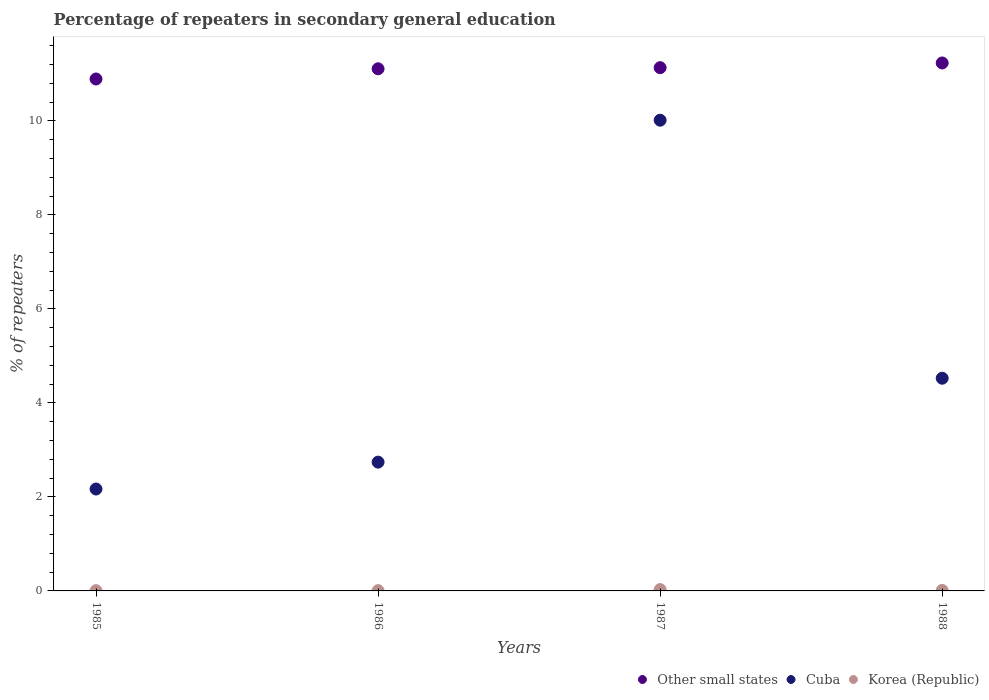How many different coloured dotlines are there?
Keep it short and to the point. 3. Is the number of dotlines equal to the number of legend labels?
Provide a short and direct response. Yes. What is the percentage of repeaters in secondary general education in Other small states in 1988?
Offer a very short reply. 11.23. Across all years, what is the maximum percentage of repeaters in secondary general education in Other small states?
Provide a succinct answer. 11.23. Across all years, what is the minimum percentage of repeaters in secondary general education in Cuba?
Offer a very short reply. 2.17. In which year was the percentage of repeaters in secondary general education in Korea (Republic) maximum?
Keep it short and to the point. 1987. What is the total percentage of repeaters in secondary general education in Korea (Republic) in the graph?
Keep it short and to the point. 0.05. What is the difference between the percentage of repeaters in secondary general education in Korea (Republic) in 1987 and that in 1988?
Give a very brief answer. 0.02. What is the difference between the percentage of repeaters in secondary general education in Korea (Republic) in 1985 and the percentage of repeaters in secondary general education in Other small states in 1987?
Keep it short and to the point. -11.13. What is the average percentage of repeaters in secondary general education in Other small states per year?
Offer a terse response. 11.09. In the year 1986, what is the difference between the percentage of repeaters in secondary general education in Other small states and percentage of repeaters in secondary general education in Korea (Republic)?
Provide a short and direct response. 11.1. In how many years, is the percentage of repeaters in secondary general education in Korea (Republic) greater than 6.8 %?
Offer a very short reply. 0. What is the ratio of the percentage of repeaters in secondary general education in Other small states in 1986 to that in 1988?
Offer a very short reply. 0.99. Is the percentage of repeaters in secondary general education in Cuba in 1986 less than that in 1988?
Ensure brevity in your answer.  Yes. Is the difference between the percentage of repeaters in secondary general education in Other small states in 1985 and 1988 greater than the difference between the percentage of repeaters in secondary general education in Korea (Republic) in 1985 and 1988?
Provide a short and direct response. No. What is the difference between the highest and the second highest percentage of repeaters in secondary general education in Other small states?
Offer a terse response. 0.1. What is the difference between the highest and the lowest percentage of repeaters in secondary general education in Korea (Republic)?
Offer a very short reply. 0.02. In how many years, is the percentage of repeaters in secondary general education in Cuba greater than the average percentage of repeaters in secondary general education in Cuba taken over all years?
Provide a succinct answer. 1. Is the sum of the percentage of repeaters in secondary general education in Korea (Republic) in 1985 and 1986 greater than the maximum percentage of repeaters in secondary general education in Cuba across all years?
Give a very brief answer. No. Is the percentage of repeaters in secondary general education in Other small states strictly less than the percentage of repeaters in secondary general education in Cuba over the years?
Your answer should be compact. No. How many dotlines are there?
Your answer should be compact. 3. Are the values on the major ticks of Y-axis written in scientific E-notation?
Keep it short and to the point. No. Where does the legend appear in the graph?
Provide a succinct answer. Bottom right. How many legend labels are there?
Ensure brevity in your answer.  3. What is the title of the graph?
Your response must be concise. Percentage of repeaters in secondary general education. Does "Peru" appear as one of the legend labels in the graph?
Your answer should be compact. No. What is the label or title of the Y-axis?
Give a very brief answer. % of repeaters. What is the % of repeaters in Other small states in 1985?
Provide a succinct answer. 10.89. What is the % of repeaters of Cuba in 1985?
Offer a terse response. 2.17. What is the % of repeaters of Korea (Republic) in 1985?
Make the answer very short. 0.01. What is the % of repeaters of Other small states in 1986?
Give a very brief answer. 11.11. What is the % of repeaters of Cuba in 1986?
Give a very brief answer. 2.74. What is the % of repeaters of Korea (Republic) in 1986?
Make the answer very short. 0.01. What is the % of repeaters of Other small states in 1987?
Give a very brief answer. 11.13. What is the % of repeaters in Cuba in 1987?
Offer a terse response. 10.01. What is the % of repeaters in Korea (Republic) in 1987?
Provide a succinct answer. 0.03. What is the % of repeaters of Other small states in 1988?
Make the answer very short. 11.23. What is the % of repeaters of Cuba in 1988?
Offer a very short reply. 4.52. What is the % of repeaters in Korea (Republic) in 1988?
Provide a succinct answer. 0.01. Across all years, what is the maximum % of repeaters of Other small states?
Your response must be concise. 11.23. Across all years, what is the maximum % of repeaters of Cuba?
Your answer should be very brief. 10.01. Across all years, what is the maximum % of repeaters of Korea (Republic)?
Offer a terse response. 0.03. Across all years, what is the minimum % of repeaters in Other small states?
Keep it short and to the point. 10.89. Across all years, what is the minimum % of repeaters in Cuba?
Make the answer very short. 2.17. Across all years, what is the minimum % of repeaters of Korea (Republic)?
Offer a very short reply. 0.01. What is the total % of repeaters of Other small states in the graph?
Offer a terse response. 44.36. What is the total % of repeaters in Cuba in the graph?
Offer a very short reply. 19.44. What is the total % of repeaters in Korea (Republic) in the graph?
Provide a succinct answer. 0.05. What is the difference between the % of repeaters of Other small states in 1985 and that in 1986?
Ensure brevity in your answer.  -0.22. What is the difference between the % of repeaters of Cuba in 1985 and that in 1986?
Offer a terse response. -0.57. What is the difference between the % of repeaters of Korea (Republic) in 1985 and that in 1986?
Give a very brief answer. -0. What is the difference between the % of repeaters of Other small states in 1985 and that in 1987?
Your answer should be very brief. -0.24. What is the difference between the % of repeaters in Cuba in 1985 and that in 1987?
Your answer should be compact. -7.85. What is the difference between the % of repeaters in Korea (Republic) in 1985 and that in 1987?
Keep it short and to the point. -0.02. What is the difference between the % of repeaters of Other small states in 1985 and that in 1988?
Your answer should be very brief. -0.34. What is the difference between the % of repeaters of Cuba in 1985 and that in 1988?
Ensure brevity in your answer.  -2.36. What is the difference between the % of repeaters of Korea (Republic) in 1985 and that in 1988?
Keep it short and to the point. -0. What is the difference between the % of repeaters in Other small states in 1986 and that in 1987?
Offer a very short reply. -0.02. What is the difference between the % of repeaters of Cuba in 1986 and that in 1987?
Keep it short and to the point. -7.27. What is the difference between the % of repeaters of Korea (Republic) in 1986 and that in 1987?
Your answer should be very brief. -0.02. What is the difference between the % of repeaters of Other small states in 1986 and that in 1988?
Offer a terse response. -0.12. What is the difference between the % of repeaters in Cuba in 1986 and that in 1988?
Make the answer very short. -1.78. What is the difference between the % of repeaters in Korea (Republic) in 1986 and that in 1988?
Ensure brevity in your answer.  -0. What is the difference between the % of repeaters in Other small states in 1987 and that in 1988?
Ensure brevity in your answer.  -0.1. What is the difference between the % of repeaters of Cuba in 1987 and that in 1988?
Provide a short and direct response. 5.49. What is the difference between the % of repeaters in Korea (Republic) in 1987 and that in 1988?
Provide a succinct answer. 0.02. What is the difference between the % of repeaters in Other small states in 1985 and the % of repeaters in Cuba in 1986?
Offer a very short reply. 8.15. What is the difference between the % of repeaters in Other small states in 1985 and the % of repeaters in Korea (Republic) in 1986?
Keep it short and to the point. 10.88. What is the difference between the % of repeaters of Cuba in 1985 and the % of repeaters of Korea (Republic) in 1986?
Provide a short and direct response. 2.16. What is the difference between the % of repeaters in Other small states in 1985 and the % of repeaters in Cuba in 1987?
Keep it short and to the point. 0.88. What is the difference between the % of repeaters in Other small states in 1985 and the % of repeaters in Korea (Republic) in 1987?
Your response must be concise. 10.86. What is the difference between the % of repeaters in Cuba in 1985 and the % of repeaters in Korea (Republic) in 1987?
Your response must be concise. 2.14. What is the difference between the % of repeaters of Other small states in 1985 and the % of repeaters of Cuba in 1988?
Give a very brief answer. 6.37. What is the difference between the % of repeaters of Other small states in 1985 and the % of repeaters of Korea (Republic) in 1988?
Offer a terse response. 10.88. What is the difference between the % of repeaters in Cuba in 1985 and the % of repeaters in Korea (Republic) in 1988?
Offer a terse response. 2.16. What is the difference between the % of repeaters of Other small states in 1986 and the % of repeaters of Cuba in 1987?
Make the answer very short. 1.09. What is the difference between the % of repeaters of Other small states in 1986 and the % of repeaters of Korea (Republic) in 1987?
Your answer should be compact. 11.08. What is the difference between the % of repeaters of Cuba in 1986 and the % of repeaters of Korea (Republic) in 1987?
Provide a succinct answer. 2.71. What is the difference between the % of repeaters in Other small states in 1986 and the % of repeaters in Cuba in 1988?
Your answer should be compact. 6.58. What is the difference between the % of repeaters of Other small states in 1986 and the % of repeaters of Korea (Republic) in 1988?
Give a very brief answer. 11.1. What is the difference between the % of repeaters in Cuba in 1986 and the % of repeaters in Korea (Republic) in 1988?
Your answer should be very brief. 2.73. What is the difference between the % of repeaters in Other small states in 1987 and the % of repeaters in Cuba in 1988?
Provide a succinct answer. 6.61. What is the difference between the % of repeaters of Other small states in 1987 and the % of repeaters of Korea (Republic) in 1988?
Provide a short and direct response. 11.12. What is the difference between the % of repeaters in Cuba in 1987 and the % of repeaters in Korea (Republic) in 1988?
Give a very brief answer. 10. What is the average % of repeaters of Other small states per year?
Provide a short and direct response. 11.09. What is the average % of repeaters of Cuba per year?
Offer a very short reply. 4.86. What is the average % of repeaters of Korea (Republic) per year?
Offer a very short reply. 0.01. In the year 1985, what is the difference between the % of repeaters of Other small states and % of repeaters of Cuba?
Offer a very short reply. 8.72. In the year 1985, what is the difference between the % of repeaters in Other small states and % of repeaters in Korea (Republic)?
Your response must be concise. 10.88. In the year 1985, what is the difference between the % of repeaters in Cuba and % of repeaters in Korea (Republic)?
Provide a short and direct response. 2.16. In the year 1986, what is the difference between the % of repeaters in Other small states and % of repeaters in Cuba?
Offer a terse response. 8.37. In the year 1986, what is the difference between the % of repeaters of Other small states and % of repeaters of Korea (Republic)?
Offer a terse response. 11.1. In the year 1986, what is the difference between the % of repeaters in Cuba and % of repeaters in Korea (Republic)?
Provide a short and direct response. 2.73. In the year 1987, what is the difference between the % of repeaters in Other small states and % of repeaters in Cuba?
Keep it short and to the point. 1.12. In the year 1987, what is the difference between the % of repeaters of Other small states and % of repeaters of Korea (Republic)?
Offer a terse response. 11.1. In the year 1987, what is the difference between the % of repeaters in Cuba and % of repeaters in Korea (Republic)?
Provide a succinct answer. 9.98. In the year 1988, what is the difference between the % of repeaters in Other small states and % of repeaters in Cuba?
Your answer should be compact. 6.71. In the year 1988, what is the difference between the % of repeaters of Other small states and % of repeaters of Korea (Republic)?
Provide a succinct answer. 11.22. In the year 1988, what is the difference between the % of repeaters of Cuba and % of repeaters of Korea (Republic)?
Your response must be concise. 4.51. What is the ratio of the % of repeaters in Other small states in 1985 to that in 1986?
Ensure brevity in your answer.  0.98. What is the ratio of the % of repeaters of Cuba in 1985 to that in 1986?
Provide a short and direct response. 0.79. What is the ratio of the % of repeaters of Korea (Republic) in 1985 to that in 1986?
Keep it short and to the point. 0.92. What is the ratio of the % of repeaters of Other small states in 1985 to that in 1987?
Your answer should be very brief. 0.98. What is the ratio of the % of repeaters of Cuba in 1985 to that in 1987?
Offer a terse response. 0.22. What is the ratio of the % of repeaters in Korea (Republic) in 1985 to that in 1987?
Your answer should be very brief. 0.19. What is the ratio of the % of repeaters in Other small states in 1985 to that in 1988?
Your response must be concise. 0.97. What is the ratio of the % of repeaters in Cuba in 1985 to that in 1988?
Offer a very short reply. 0.48. What is the ratio of the % of repeaters in Korea (Republic) in 1985 to that in 1988?
Ensure brevity in your answer.  0.54. What is the ratio of the % of repeaters of Other small states in 1986 to that in 1987?
Your answer should be very brief. 1. What is the ratio of the % of repeaters of Cuba in 1986 to that in 1987?
Ensure brevity in your answer.  0.27. What is the ratio of the % of repeaters of Korea (Republic) in 1986 to that in 1987?
Offer a terse response. 0.21. What is the ratio of the % of repeaters in Cuba in 1986 to that in 1988?
Give a very brief answer. 0.61. What is the ratio of the % of repeaters of Korea (Republic) in 1986 to that in 1988?
Your answer should be compact. 0.58. What is the ratio of the % of repeaters in Cuba in 1987 to that in 1988?
Your answer should be compact. 2.21. What is the ratio of the % of repeaters in Korea (Republic) in 1987 to that in 1988?
Keep it short and to the point. 2.79. What is the difference between the highest and the second highest % of repeaters of Other small states?
Provide a succinct answer. 0.1. What is the difference between the highest and the second highest % of repeaters of Cuba?
Keep it short and to the point. 5.49. What is the difference between the highest and the second highest % of repeaters in Korea (Republic)?
Your response must be concise. 0.02. What is the difference between the highest and the lowest % of repeaters in Other small states?
Keep it short and to the point. 0.34. What is the difference between the highest and the lowest % of repeaters of Cuba?
Give a very brief answer. 7.85. What is the difference between the highest and the lowest % of repeaters in Korea (Republic)?
Ensure brevity in your answer.  0.02. 